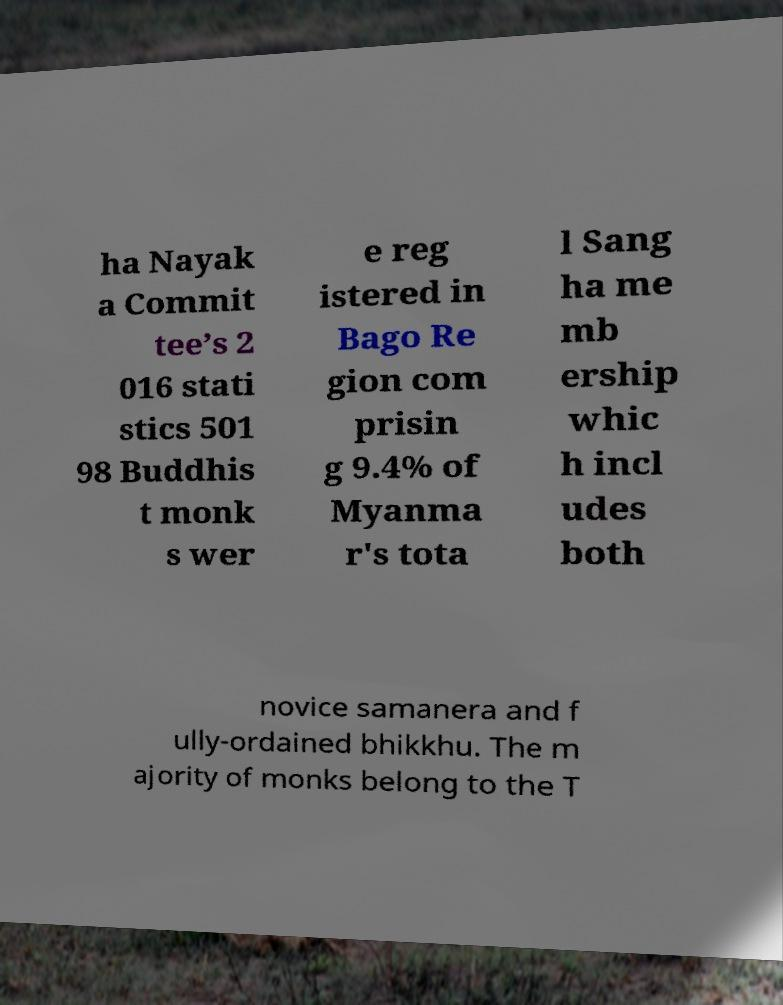Please identify and transcribe the text found in this image. ha Nayak a Commit tee’s 2 016 stati stics 501 98 Buddhis t monk s wer e reg istered in Bago Re gion com prisin g 9.4% of Myanma r's tota l Sang ha me mb ership whic h incl udes both novice samanera and f ully-ordained bhikkhu. The m ajority of monks belong to the T 